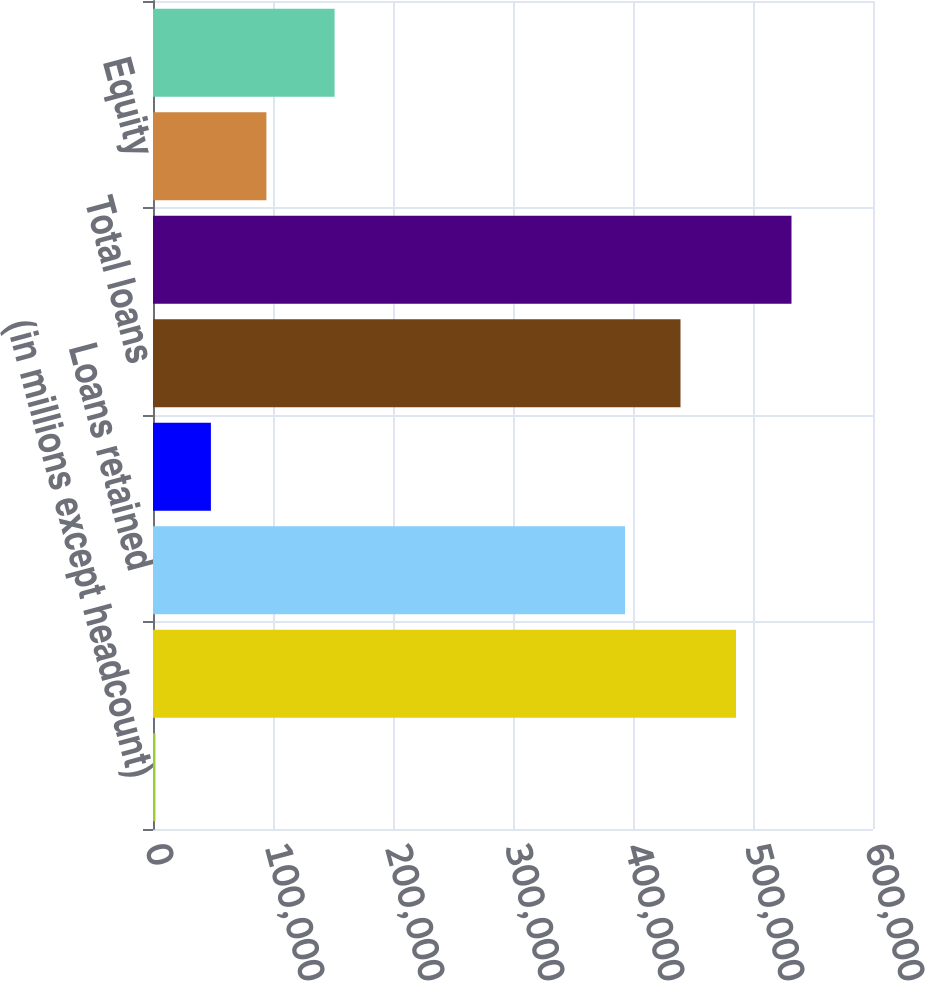<chart> <loc_0><loc_0><loc_500><loc_500><bar_chart><fcel>(in millions except headcount)<fcel>Total assets<fcel>Loans retained<fcel>Loans held-for-sale and loans<fcel>Total loans<fcel>Deposits<fcel>Equity<fcel>Headcount (a)<nl><fcel>2013<fcel>485831<fcel>393351<fcel>48252.9<fcel>439591<fcel>532071<fcel>94492.8<fcel>151333<nl></chart> 